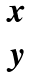<formula> <loc_0><loc_0><loc_500><loc_500>\begin{matrix} x \\ y \\ \end{matrix}</formula> 